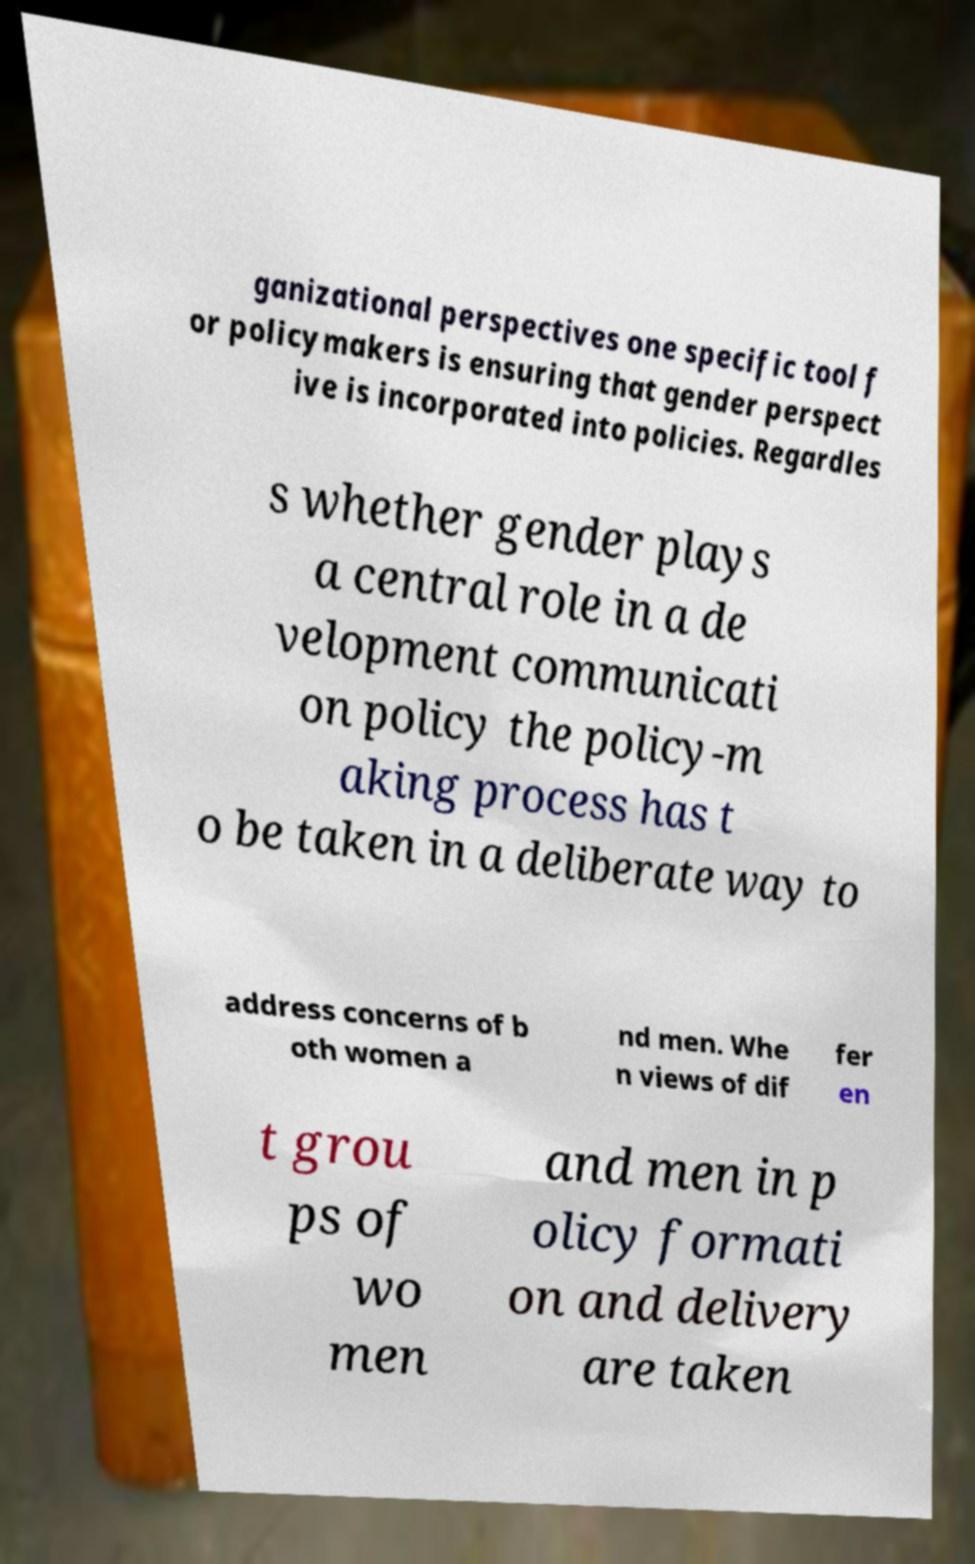Could you extract and type out the text from this image? ganizational perspectives one specific tool f or policymakers is ensuring that gender perspect ive is incorporated into policies. Regardles s whether gender plays a central role in a de velopment communicati on policy the policy-m aking process has t o be taken in a deliberate way to address concerns of b oth women a nd men. Whe n views of dif fer en t grou ps of wo men and men in p olicy formati on and delivery are taken 